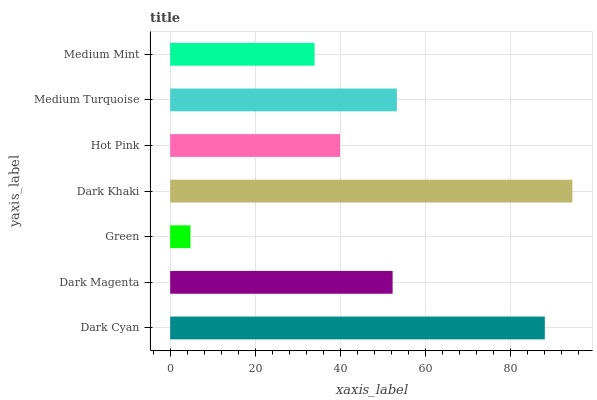Is Green the minimum?
Answer yes or no. Yes. Is Dark Khaki the maximum?
Answer yes or no. Yes. Is Dark Magenta the minimum?
Answer yes or no. No. Is Dark Magenta the maximum?
Answer yes or no. No. Is Dark Cyan greater than Dark Magenta?
Answer yes or no. Yes. Is Dark Magenta less than Dark Cyan?
Answer yes or no. Yes. Is Dark Magenta greater than Dark Cyan?
Answer yes or no. No. Is Dark Cyan less than Dark Magenta?
Answer yes or no. No. Is Dark Magenta the high median?
Answer yes or no. Yes. Is Dark Magenta the low median?
Answer yes or no. Yes. Is Dark Khaki the high median?
Answer yes or no. No. Is Green the low median?
Answer yes or no. No. 